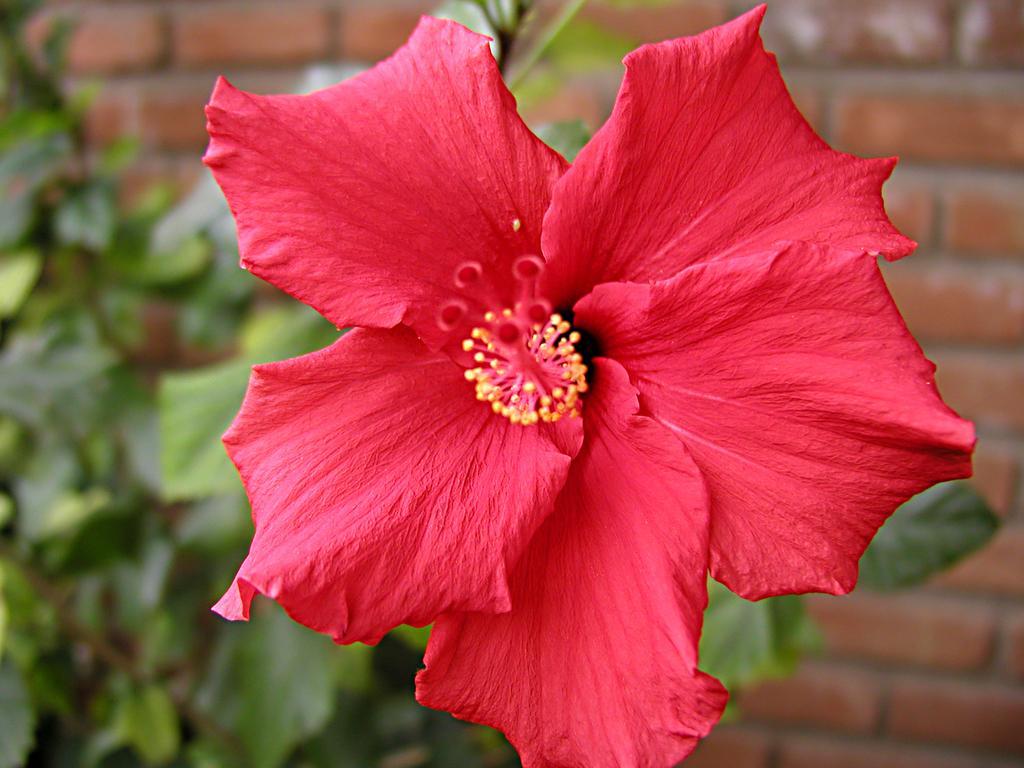How would you summarize this image in a sentence or two? In this picture i can see a flower. In the background i can see plant and a brick wall. 